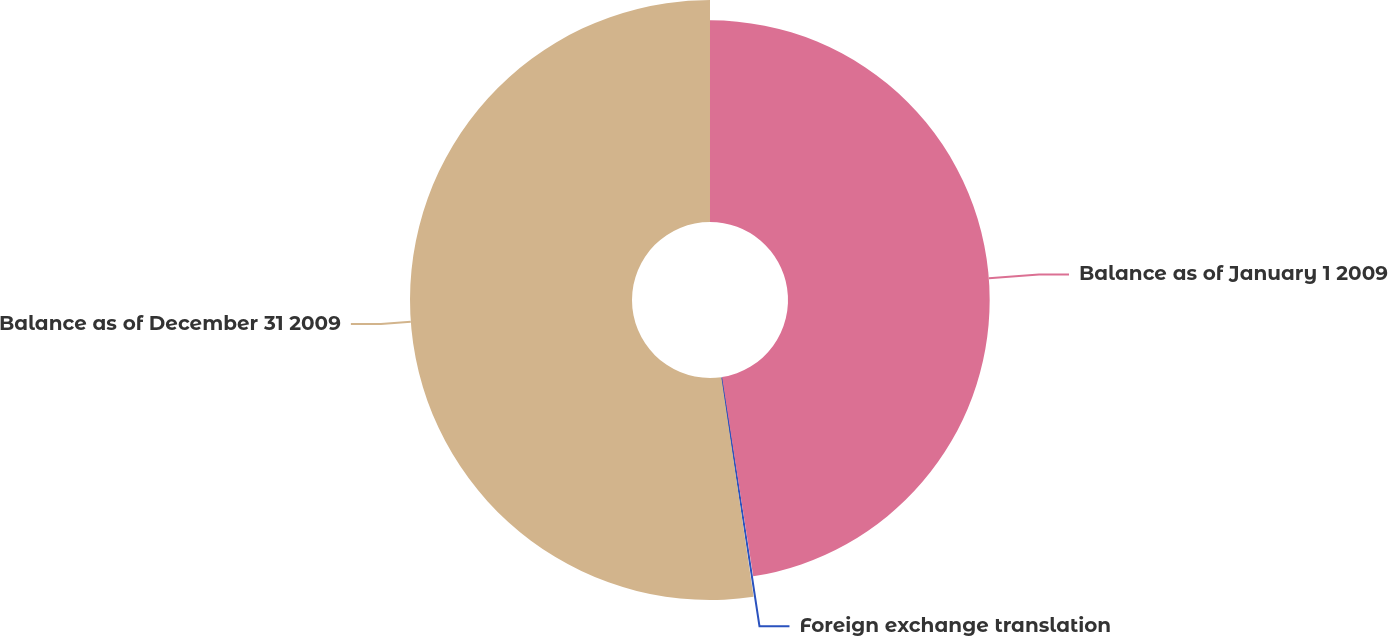Convert chart. <chart><loc_0><loc_0><loc_500><loc_500><pie_chart><fcel>Balance as of January 1 2009<fcel>Foreign exchange translation<fcel>Balance as of December 31 2009<nl><fcel>47.53%<fcel>0.15%<fcel>52.32%<nl></chart> 